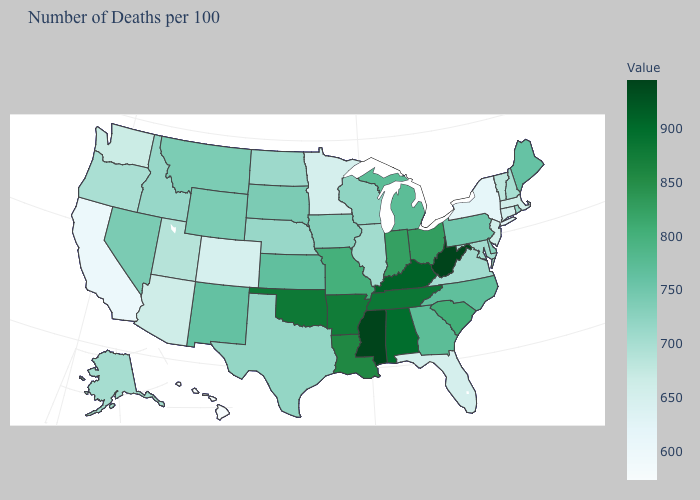Does the map have missing data?
Be succinct. No. Is the legend a continuous bar?
Give a very brief answer. Yes. Does New York have the lowest value in the Northeast?
Concise answer only. Yes. Does Rhode Island have the lowest value in the USA?
Concise answer only. No. 